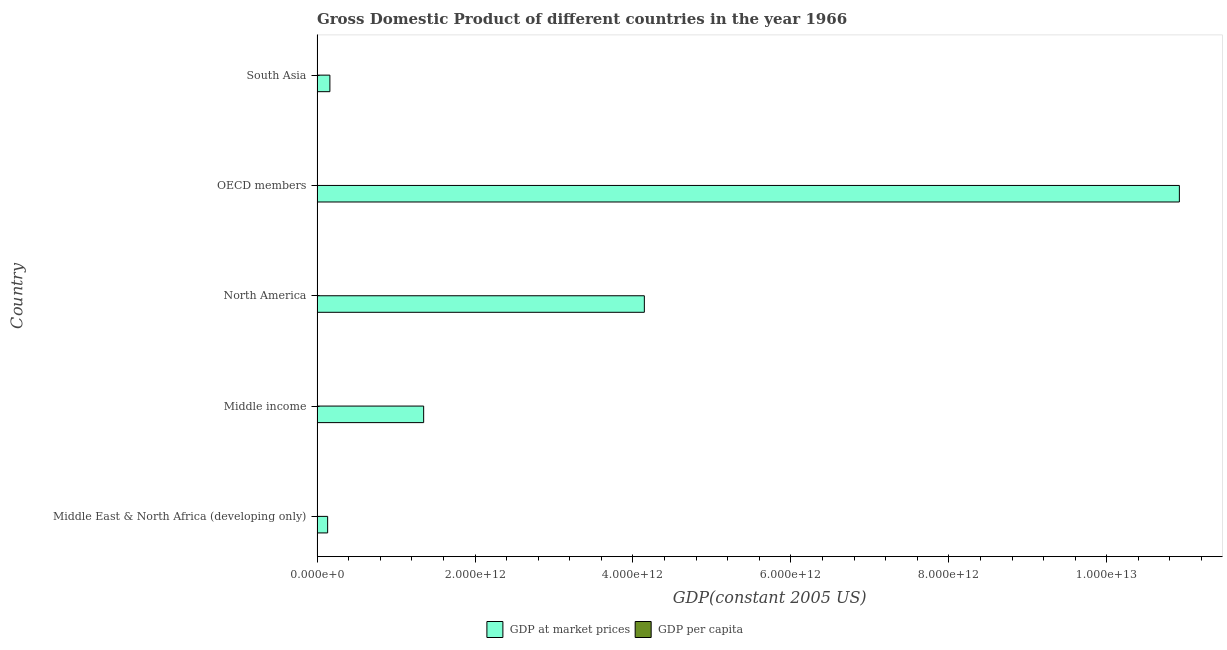Are the number of bars per tick equal to the number of legend labels?
Make the answer very short. Yes. Are the number of bars on each tick of the Y-axis equal?
Make the answer very short. Yes. How many bars are there on the 3rd tick from the top?
Your answer should be compact. 2. What is the label of the 5th group of bars from the top?
Make the answer very short. Middle East & North Africa (developing only). In how many cases, is the number of bars for a given country not equal to the number of legend labels?
Ensure brevity in your answer.  0. What is the gdp per capita in Middle income?
Offer a terse response. 603.42. Across all countries, what is the maximum gdp at market prices?
Give a very brief answer. 1.09e+13. Across all countries, what is the minimum gdp per capita?
Ensure brevity in your answer.  249.67. What is the total gdp at market prices in the graph?
Your answer should be very brief. 1.67e+13. What is the difference between the gdp per capita in Middle income and that in North America?
Make the answer very short. -1.85e+04. What is the difference between the gdp at market prices in Middle income and the gdp per capita in OECD members?
Make the answer very short. 1.35e+12. What is the average gdp at market prices per country?
Offer a very short reply. 3.34e+12. What is the difference between the gdp per capita and gdp at market prices in Middle East & North Africa (developing only)?
Provide a short and direct response. -1.34e+11. In how many countries, is the gdp per capita greater than 10800000000000 US$?
Your response must be concise. 0. What is the ratio of the gdp per capita in Middle East & North Africa (developing only) to that in North America?
Ensure brevity in your answer.  0.06. Is the difference between the gdp per capita in OECD members and South Asia greater than the difference between the gdp at market prices in OECD members and South Asia?
Offer a very short reply. No. What is the difference between the highest and the second highest gdp at market prices?
Your response must be concise. 6.78e+12. What is the difference between the highest and the lowest gdp at market prices?
Your response must be concise. 1.08e+13. What does the 2nd bar from the top in OECD members represents?
Keep it short and to the point. GDP at market prices. What does the 2nd bar from the bottom in North America represents?
Make the answer very short. GDP per capita. Are all the bars in the graph horizontal?
Keep it short and to the point. Yes. How many countries are there in the graph?
Your response must be concise. 5. What is the difference between two consecutive major ticks on the X-axis?
Your response must be concise. 2.00e+12. Are the values on the major ticks of X-axis written in scientific E-notation?
Your answer should be compact. Yes. Does the graph contain any zero values?
Provide a short and direct response. No. What is the title of the graph?
Keep it short and to the point. Gross Domestic Product of different countries in the year 1966. Does "Stunting" appear as one of the legend labels in the graph?
Keep it short and to the point. No. What is the label or title of the X-axis?
Offer a very short reply. GDP(constant 2005 US). What is the GDP(constant 2005 US) of GDP at market prices in Middle East & North Africa (developing only)?
Offer a terse response. 1.34e+11. What is the GDP(constant 2005 US) in GDP per capita in Middle East & North Africa (developing only)?
Your response must be concise. 1168.02. What is the GDP(constant 2005 US) of GDP at market prices in Middle income?
Make the answer very short. 1.35e+12. What is the GDP(constant 2005 US) of GDP per capita in Middle income?
Offer a very short reply. 603.42. What is the GDP(constant 2005 US) in GDP at market prices in North America?
Your response must be concise. 4.14e+12. What is the GDP(constant 2005 US) of GDP per capita in North America?
Your answer should be compact. 1.91e+04. What is the GDP(constant 2005 US) of GDP at market prices in OECD members?
Make the answer very short. 1.09e+13. What is the GDP(constant 2005 US) in GDP per capita in OECD members?
Give a very brief answer. 1.28e+04. What is the GDP(constant 2005 US) in GDP at market prices in South Asia?
Offer a terse response. 1.63e+11. What is the GDP(constant 2005 US) in GDP per capita in South Asia?
Provide a short and direct response. 249.67. Across all countries, what is the maximum GDP(constant 2005 US) of GDP at market prices?
Your response must be concise. 1.09e+13. Across all countries, what is the maximum GDP(constant 2005 US) in GDP per capita?
Give a very brief answer. 1.91e+04. Across all countries, what is the minimum GDP(constant 2005 US) of GDP at market prices?
Keep it short and to the point. 1.34e+11. Across all countries, what is the minimum GDP(constant 2005 US) in GDP per capita?
Give a very brief answer. 249.67. What is the total GDP(constant 2005 US) of GDP at market prices in the graph?
Offer a terse response. 1.67e+13. What is the total GDP(constant 2005 US) of GDP per capita in the graph?
Provide a short and direct response. 3.40e+04. What is the difference between the GDP(constant 2005 US) of GDP at market prices in Middle East & North Africa (developing only) and that in Middle income?
Your answer should be compact. -1.22e+12. What is the difference between the GDP(constant 2005 US) of GDP per capita in Middle East & North Africa (developing only) and that in Middle income?
Offer a terse response. 564.6. What is the difference between the GDP(constant 2005 US) in GDP at market prices in Middle East & North Africa (developing only) and that in North America?
Offer a very short reply. -4.01e+12. What is the difference between the GDP(constant 2005 US) in GDP per capita in Middle East & North Africa (developing only) and that in North America?
Your answer should be compact. -1.80e+04. What is the difference between the GDP(constant 2005 US) in GDP at market prices in Middle East & North Africa (developing only) and that in OECD members?
Ensure brevity in your answer.  -1.08e+13. What is the difference between the GDP(constant 2005 US) in GDP per capita in Middle East & North Africa (developing only) and that in OECD members?
Give a very brief answer. -1.16e+04. What is the difference between the GDP(constant 2005 US) of GDP at market prices in Middle East & North Africa (developing only) and that in South Asia?
Keep it short and to the point. -2.85e+1. What is the difference between the GDP(constant 2005 US) of GDP per capita in Middle East & North Africa (developing only) and that in South Asia?
Keep it short and to the point. 918.35. What is the difference between the GDP(constant 2005 US) in GDP at market prices in Middle income and that in North America?
Provide a short and direct response. -2.79e+12. What is the difference between the GDP(constant 2005 US) in GDP per capita in Middle income and that in North America?
Offer a very short reply. -1.85e+04. What is the difference between the GDP(constant 2005 US) in GDP at market prices in Middle income and that in OECD members?
Your response must be concise. -9.57e+12. What is the difference between the GDP(constant 2005 US) of GDP per capita in Middle income and that in OECD members?
Your answer should be very brief. -1.22e+04. What is the difference between the GDP(constant 2005 US) of GDP at market prices in Middle income and that in South Asia?
Keep it short and to the point. 1.19e+12. What is the difference between the GDP(constant 2005 US) in GDP per capita in Middle income and that in South Asia?
Your answer should be compact. 353.75. What is the difference between the GDP(constant 2005 US) of GDP at market prices in North America and that in OECD members?
Your answer should be compact. -6.78e+12. What is the difference between the GDP(constant 2005 US) of GDP per capita in North America and that in OECD members?
Keep it short and to the point. 6313.39. What is the difference between the GDP(constant 2005 US) in GDP at market prices in North America and that in South Asia?
Your answer should be very brief. 3.98e+12. What is the difference between the GDP(constant 2005 US) of GDP per capita in North America and that in South Asia?
Keep it short and to the point. 1.89e+04. What is the difference between the GDP(constant 2005 US) of GDP at market prices in OECD members and that in South Asia?
Ensure brevity in your answer.  1.08e+13. What is the difference between the GDP(constant 2005 US) of GDP per capita in OECD members and that in South Asia?
Your response must be concise. 1.26e+04. What is the difference between the GDP(constant 2005 US) in GDP at market prices in Middle East & North Africa (developing only) and the GDP(constant 2005 US) in GDP per capita in Middle income?
Your answer should be compact. 1.34e+11. What is the difference between the GDP(constant 2005 US) in GDP at market prices in Middle East & North Africa (developing only) and the GDP(constant 2005 US) in GDP per capita in North America?
Your response must be concise. 1.34e+11. What is the difference between the GDP(constant 2005 US) of GDP at market prices in Middle East & North Africa (developing only) and the GDP(constant 2005 US) of GDP per capita in OECD members?
Provide a short and direct response. 1.34e+11. What is the difference between the GDP(constant 2005 US) in GDP at market prices in Middle East & North Africa (developing only) and the GDP(constant 2005 US) in GDP per capita in South Asia?
Your answer should be very brief. 1.34e+11. What is the difference between the GDP(constant 2005 US) in GDP at market prices in Middle income and the GDP(constant 2005 US) in GDP per capita in North America?
Your answer should be very brief. 1.35e+12. What is the difference between the GDP(constant 2005 US) of GDP at market prices in Middle income and the GDP(constant 2005 US) of GDP per capita in OECD members?
Offer a terse response. 1.35e+12. What is the difference between the GDP(constant 2005 US) in GDP at market prices in Middle income and the GDP(constant 2005 US) in GDP per capita in South Asia?
Your answer should be very brief. 1.35e+12. What is the difference between the GDP(constant 2005 US) in GDP at market prices in North America and the GDP(constant 2005 US) in GDP per capita in OECD members?
Provide a short and direct response. 4.14e+12. What is the difference between the GDP(constant 2005 US) of GDP at market prices in North America and the GDP(constant 2005 US) of GDP per capita in South Asia?
Keep it short and to the point. 4.14e+12. What is the difference between the GDP(constant 2005 US) of GDP at market prices in OECD members and the GDP(constant 2005 US) of GDP per capita in South Asia?
Your answer should be very brief. 1.09e+13. What is the average GDP(constant 2005 US) in GDP at market prices per country?
Offer a terse response. 3.34e+12. What is the average GDP(constant 2005 US) of GDP per capita per country?
Offer a terse response. 6792.89. What is the difference between the GDP(constant 2005 US) of GDP at market prices and GDP(constant 2005 US) of GDP per capita in Middle East & North Africa (developing only)?
Keep it short and to the point. 1.34e+11. What is the difference between the GDP(constant 2005 US) of GDP at market prices and GDP(constant 2005 US) of GDP per capita in Middle income?
Make the answer very short. 1.35e+12. What is the difference between the GDP(constant 2005 US) in GDP at market prices and GDP(constant 2005 US) in GDP per capita in North America?
Keep it short and to the point. 4.14e+12. What is the difference between the GDP(constant 2005 US) in GDP at market prices and GDP(constant 2005 US) in GDP per capita in OECD members?
Your response must be concise. 1.09e+13. What is the difference between the GDP(constant 2005 US) in GDP at market prices and GDP(constant 2005 US) in GDP per capita in South Asia?
Give a very brief answer. 1.63e+11. What is the ratio of the GDP(constant 2005 US) of GDP at market prices in Middle East & North Africa (developing only) to that in Middle income?
Offer a terse response. 0.1. What is the ratio of the GDP(constant 2005 US) of GDP per capita in Middle East & North Africa (developing only) to that in Middle income?
Make the answer very short. 1.94. What is the ratio of the GDP(constant 2005 US) in GDP at market prices in Middle East & North Africa (developing only) to that in North America?
Offer a very short reply. 0.03. What is the ratio of the GDP(constant 2005 US) of GDP per capita in Middle East & North Africa (developing only) to that in North America?
Your answer should be compact. 0.06. What is the ratio of the GDP(constant 2005 US) of GDP at market prices in Middle East & North Africa (developing only) to that in OECD members?
Make the answer very short. 0.01. What is the ratio of the GDP(constant 2005 US) in GDP per capita in Middle East & North Africa (developing only) to that in OECD members?
Offer a very short reply. 0.09. What is the ratio of the GDP(constant 2005 US) in GDP at market prices in Middle East & North Africa (developing only) to that in South Asia?
Your answer should be compact. 0.82. What is the ratio of the GDP(constant 2005 US) in GDP per capita in Middle East & North Africa (developing only) to that in South Asia?
Your answer should be compact. 4.68. What is the ratio of the GDP(constant 2005 US) in GDP at market prices in Middle income to that in North America?
Give a very brief answer. 0.33. What is the ratio of the GDP(constant 2005 US) in GDP per capita in Middle income to that in North America?
Give a very brief answer. 0.03. What is the ratio of the GDP(constant 2005 US) in GDP at market prices in Middle income to that in OECD members?
Your answer should be very brief. 0.12. What is the ratio of the GDP(constant 2005 US) of GDP per capita in Middle income to that in OECD members?
Offer a very short reply. 0.05. What is the ratio of the GDP(constant 2005 US) in GDP at market prices in Middle income to that in South Asia?
Offer a very short reply. 8.3. What is the ratio of the GDP(constant 2005 US) in GDP per capita in Middle income to that in South Asia?
Your answer should be compact. 2.42. What is the ratio of the GDP(constant 2005 US) of GDP at market prices in North America to that in OECD members?
Your answer should be very brief. 0.38. What is the ratio of the GDP(constant 2005 US) in GDP per capita in North America to that in OECD members?
Your answer should be compact. 1.49. What is the ratio of the GDP(constant 2005 US) of GDP at market prices in North America to that in South Asia?
Keep it short and to the point. 25.49. What is the ratio of the GDP(constant 2005 US) in GDP per capita in North America to that in South Asia?
Offer a terse response. 76.62. What is the ratio of the GDP(constant 2005 US) of GDP at market prices in OECD members to that in South Asia?
Keep it short and to the point. 67.15. What is the ratio of the GDP(constant 2005 US) in GDP per capita in OECD members to that in South Asia?
Your answer should be compact. 51.33. What is the difference between the highest and the second highest GDP(constant 2005 US) of GDP at market prices?
Offer a terse response. 6.78e+12. What is the difference between the highest and the second highest GDP(constant 2005 US) in GDP per capita?
Give a very brief answer. 6313.39. What is the difference between the highest and the lowest GDP(constant 2005 US) of GDP at market prices?
Provide a short and direct response. 1.08e+13. What is the difference between the highest and the lowest GDP(constant 2005 US) of GDP per capita?
Offer a very short reply. 1.89e+04. 